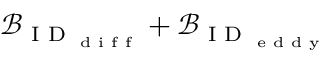Convert formula to latex. <formula><loc_0><loc_0><loc_500><loc_500>\mathcal { B } _ { I D _ { d i f f } } + \mathcal { B } _ { I D _ { e d d y } }</formula> 